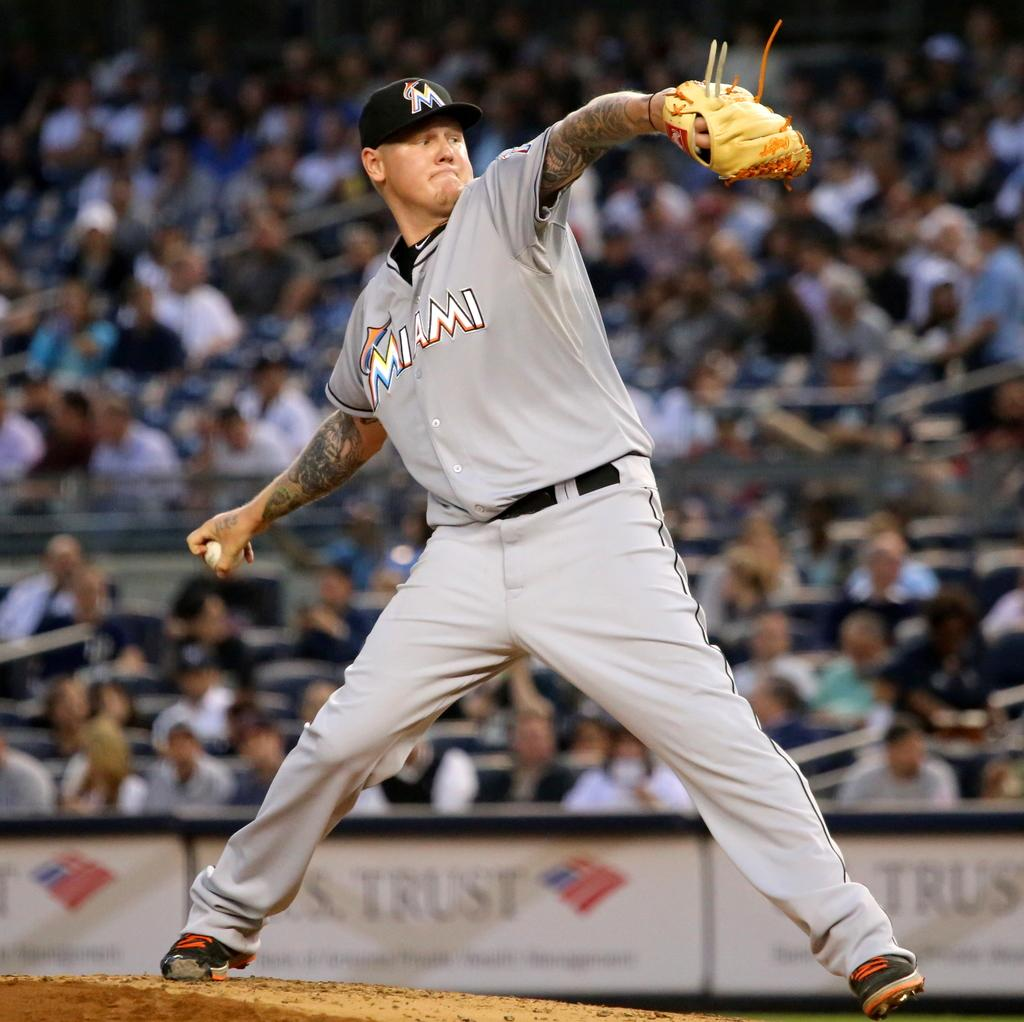Provide a one-sentence caption for the provided image. A pitcher for Miami winding up his pitch. 